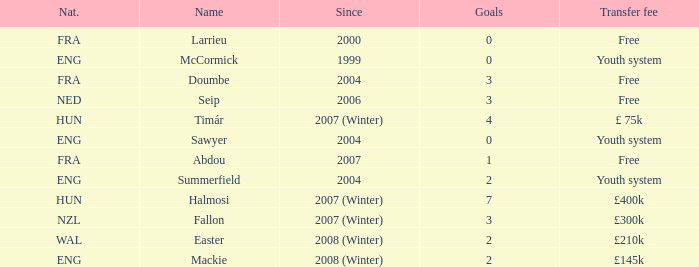What the since year of the player with a transfer fee of £ 75k? 2007 (Winter). 